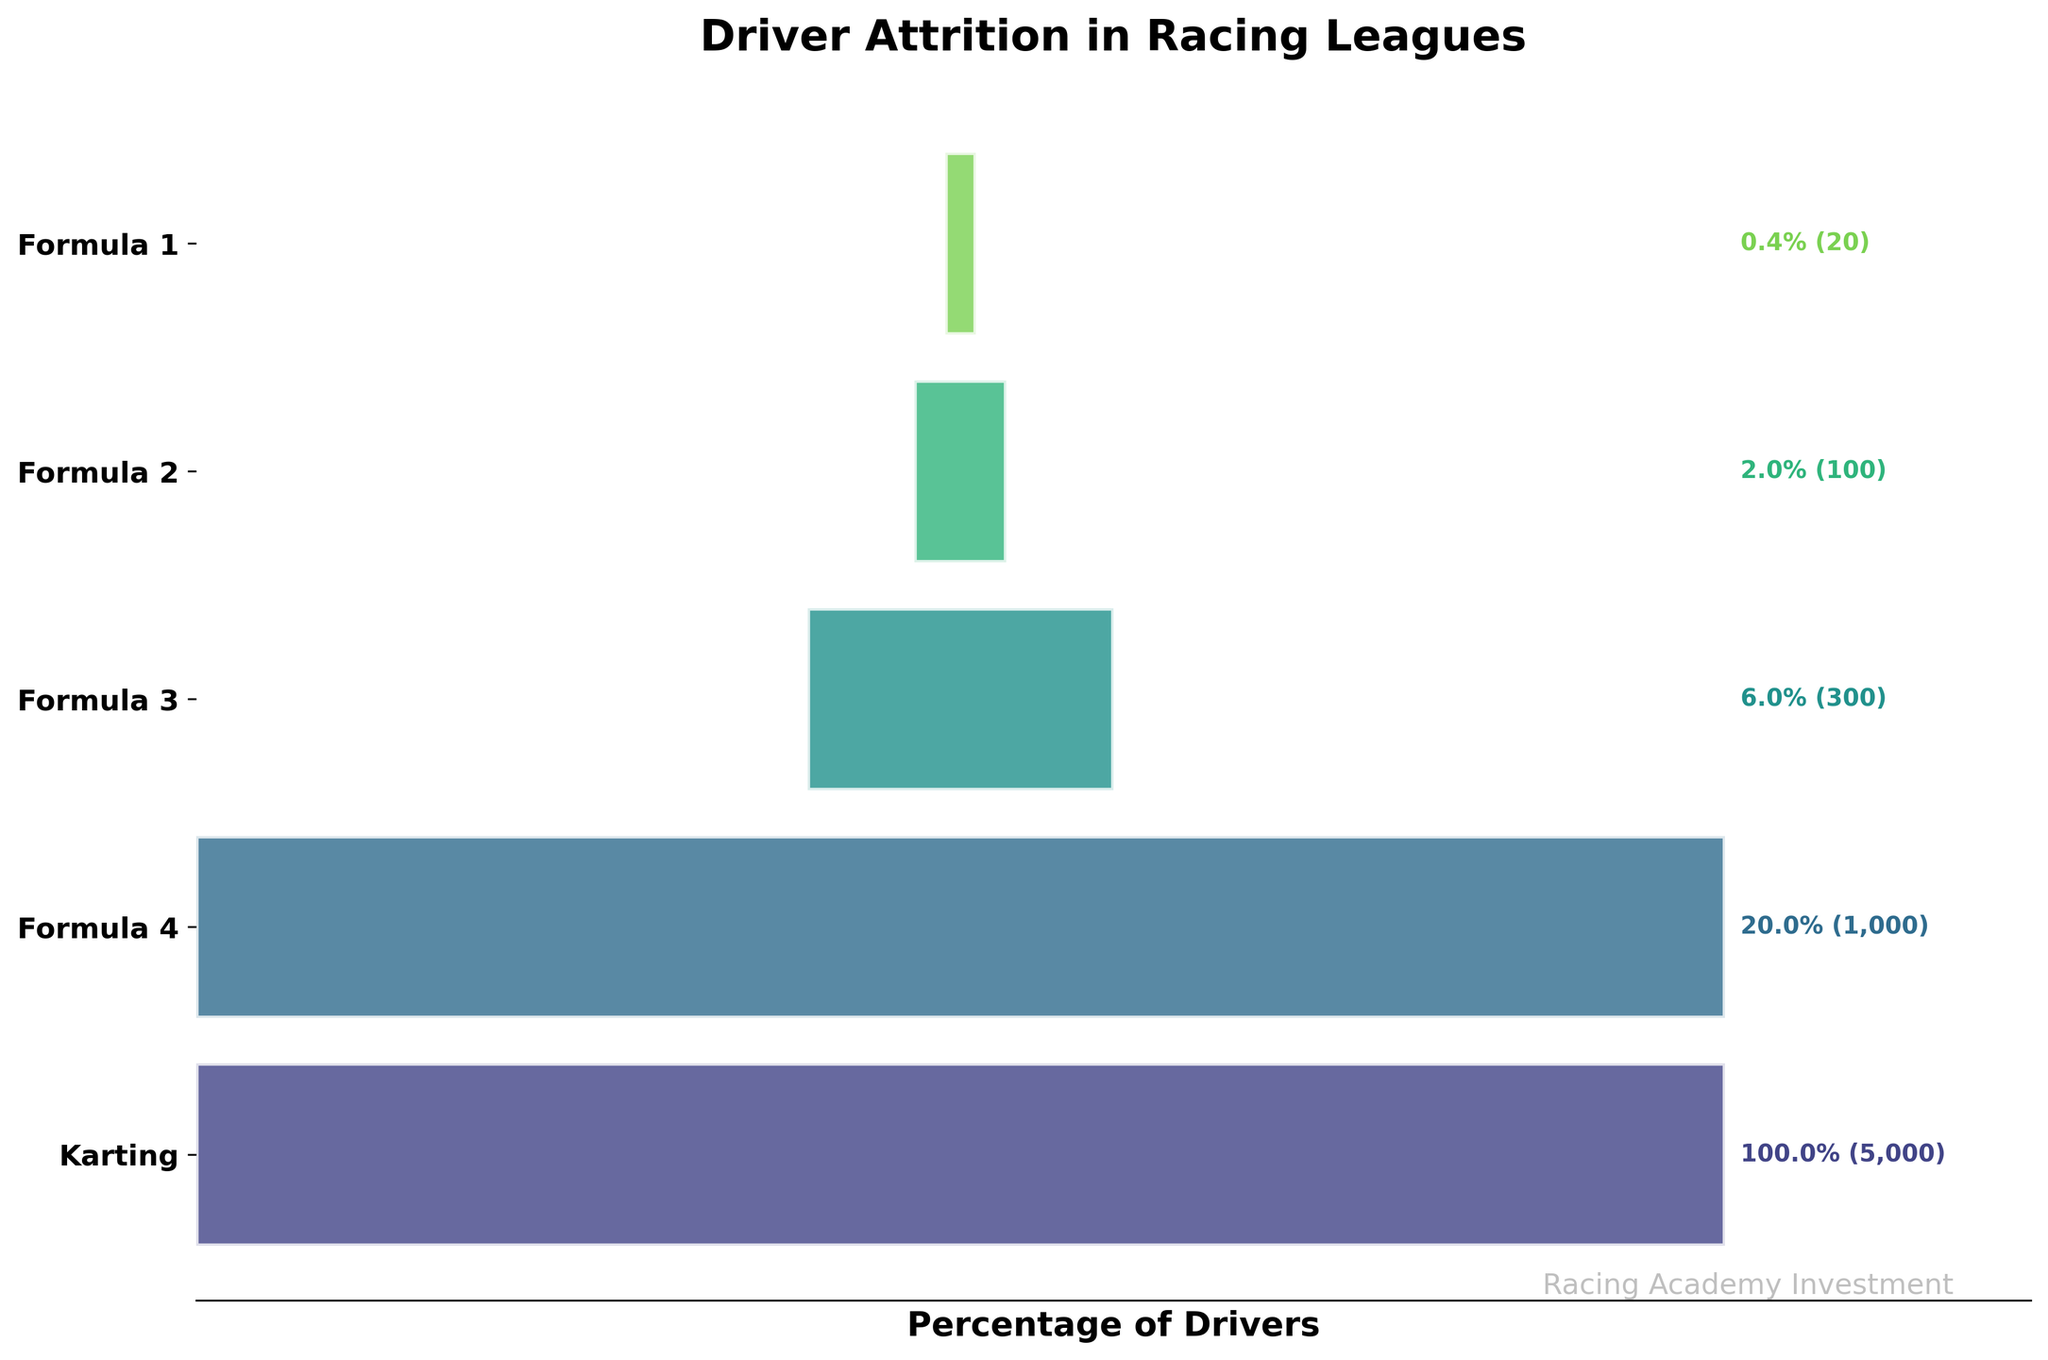What is the title of the funnel chart? The title of the funnel chart is usually displayed at the top of the plot. Here it is clearly visible as "Driver Attrition in Racing Leagues".
Answer: Driver Attrition in Racing Leagues How many stages are represented in the funnel chart? To determine the number of stages, count the different levels displayed in the chart. From the stages listed, we can see that there are 5 stages: Karting, Formula 4, Formula 3, Formula 2, and Formula 1.
Answer: 5 Which stage has the highest attrition rate? Attrition rate can be inferred by observing the percentage drop between stages. The largest drop in the number of drivers occurs from Karting (5000 drivers) to Formula 4 (1000 drivers), which indicates the most significant attrition rate.
Answer: Karting to Formula 4 What percentage of drivers make it from Formula 2 to Formula 1? Look at the given percentages for Formula 2 and Formula 1. Formula 2 has 2% and Formula 1 has 0.4%. Thus, a drop from 2% to 0.4% indicates this percentage. Calculate it as (0.4/2)*100%.
Answer: 20% How many drivers move from Karting to professional Formula 1 racing? Start with the number of drivers in Karting (5000) and see how many make it to Formula 1 (20). The absolute number of drivers making this transition is thus 20.
Answer: 20 How does the number of drivers in Formula 4 compare to those in Formula 3? To find this, compare the number of drivers in each stage. Formula 4 has 1000 drivers, while Formula 3 has 300.
Answer: Formula 4 has more drivers than Formula 3 What is the percentage drop of drivers from Karting to Formula 3? Calculate the percentage drop by subtracting the percentage of drivers remaining in Formula 3 from those in Karting: (100% - 6%) = 94%.
Answer: 94% What is the relative decrease in the number of drivers from Formula 3 to Formula 2? This involves calculating the decrease in drivers and then relative decrease. Formula 3 has 300 drivers, and Formula 2 has 100. The relative decrease is ((300-100)/300)*100%.
Answer: 66.7% Which stage marks the transition where less than 10% of the drivers remain? Check the percentages listed beside each stage. The switch from Formula 4 (20%) to Formula 3 (6%) marks the transition where less than 10% of the drivers remain.
Answer: Formula 3 Are there any stages where exactly half of the drivers transition to the next stage? Compare the number of drivers between each consecutive pair of stages. However, as observed, there is no stage where the number of drivers is exactly halved compared to the previous stage in this particular chart.
Answer: No 